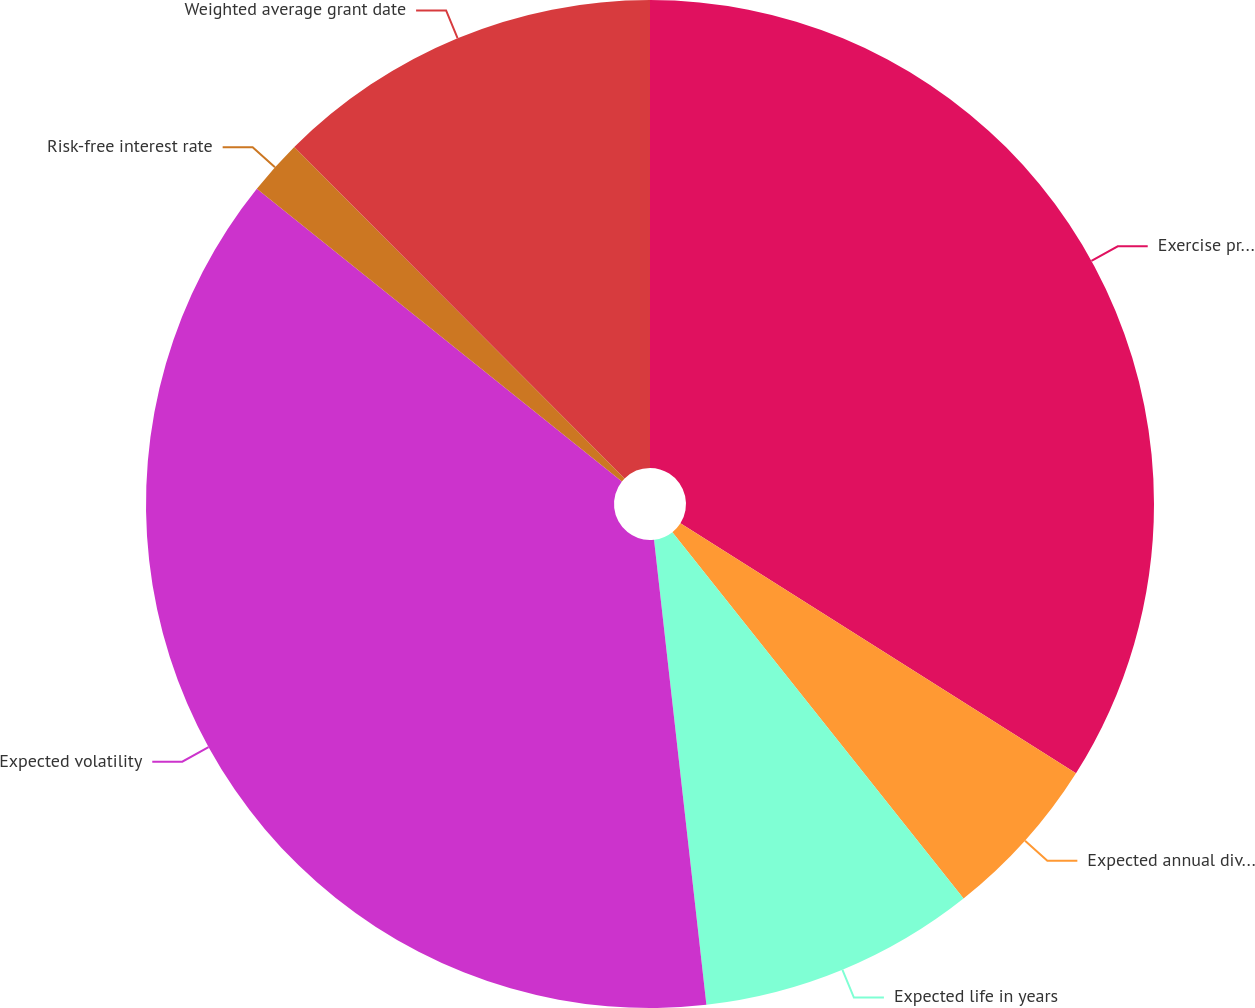Convert chart to OTSL. <chart><loc_0><loc_0><loc_500><loc_500><pie_chart><fcel>Exercise price per share<fcel>Expected annual dividend yield<fcel>Expected life in years<fcel>Expected volatility<fcel>Risk-free interest rate<fcel>Weighted average grant date<nl><fcel>33.97%<fcel>5.34%<fcel>8.9%<fcel>37.54%<fcel>1.77%<fcel>12.47%<nl></chart> 